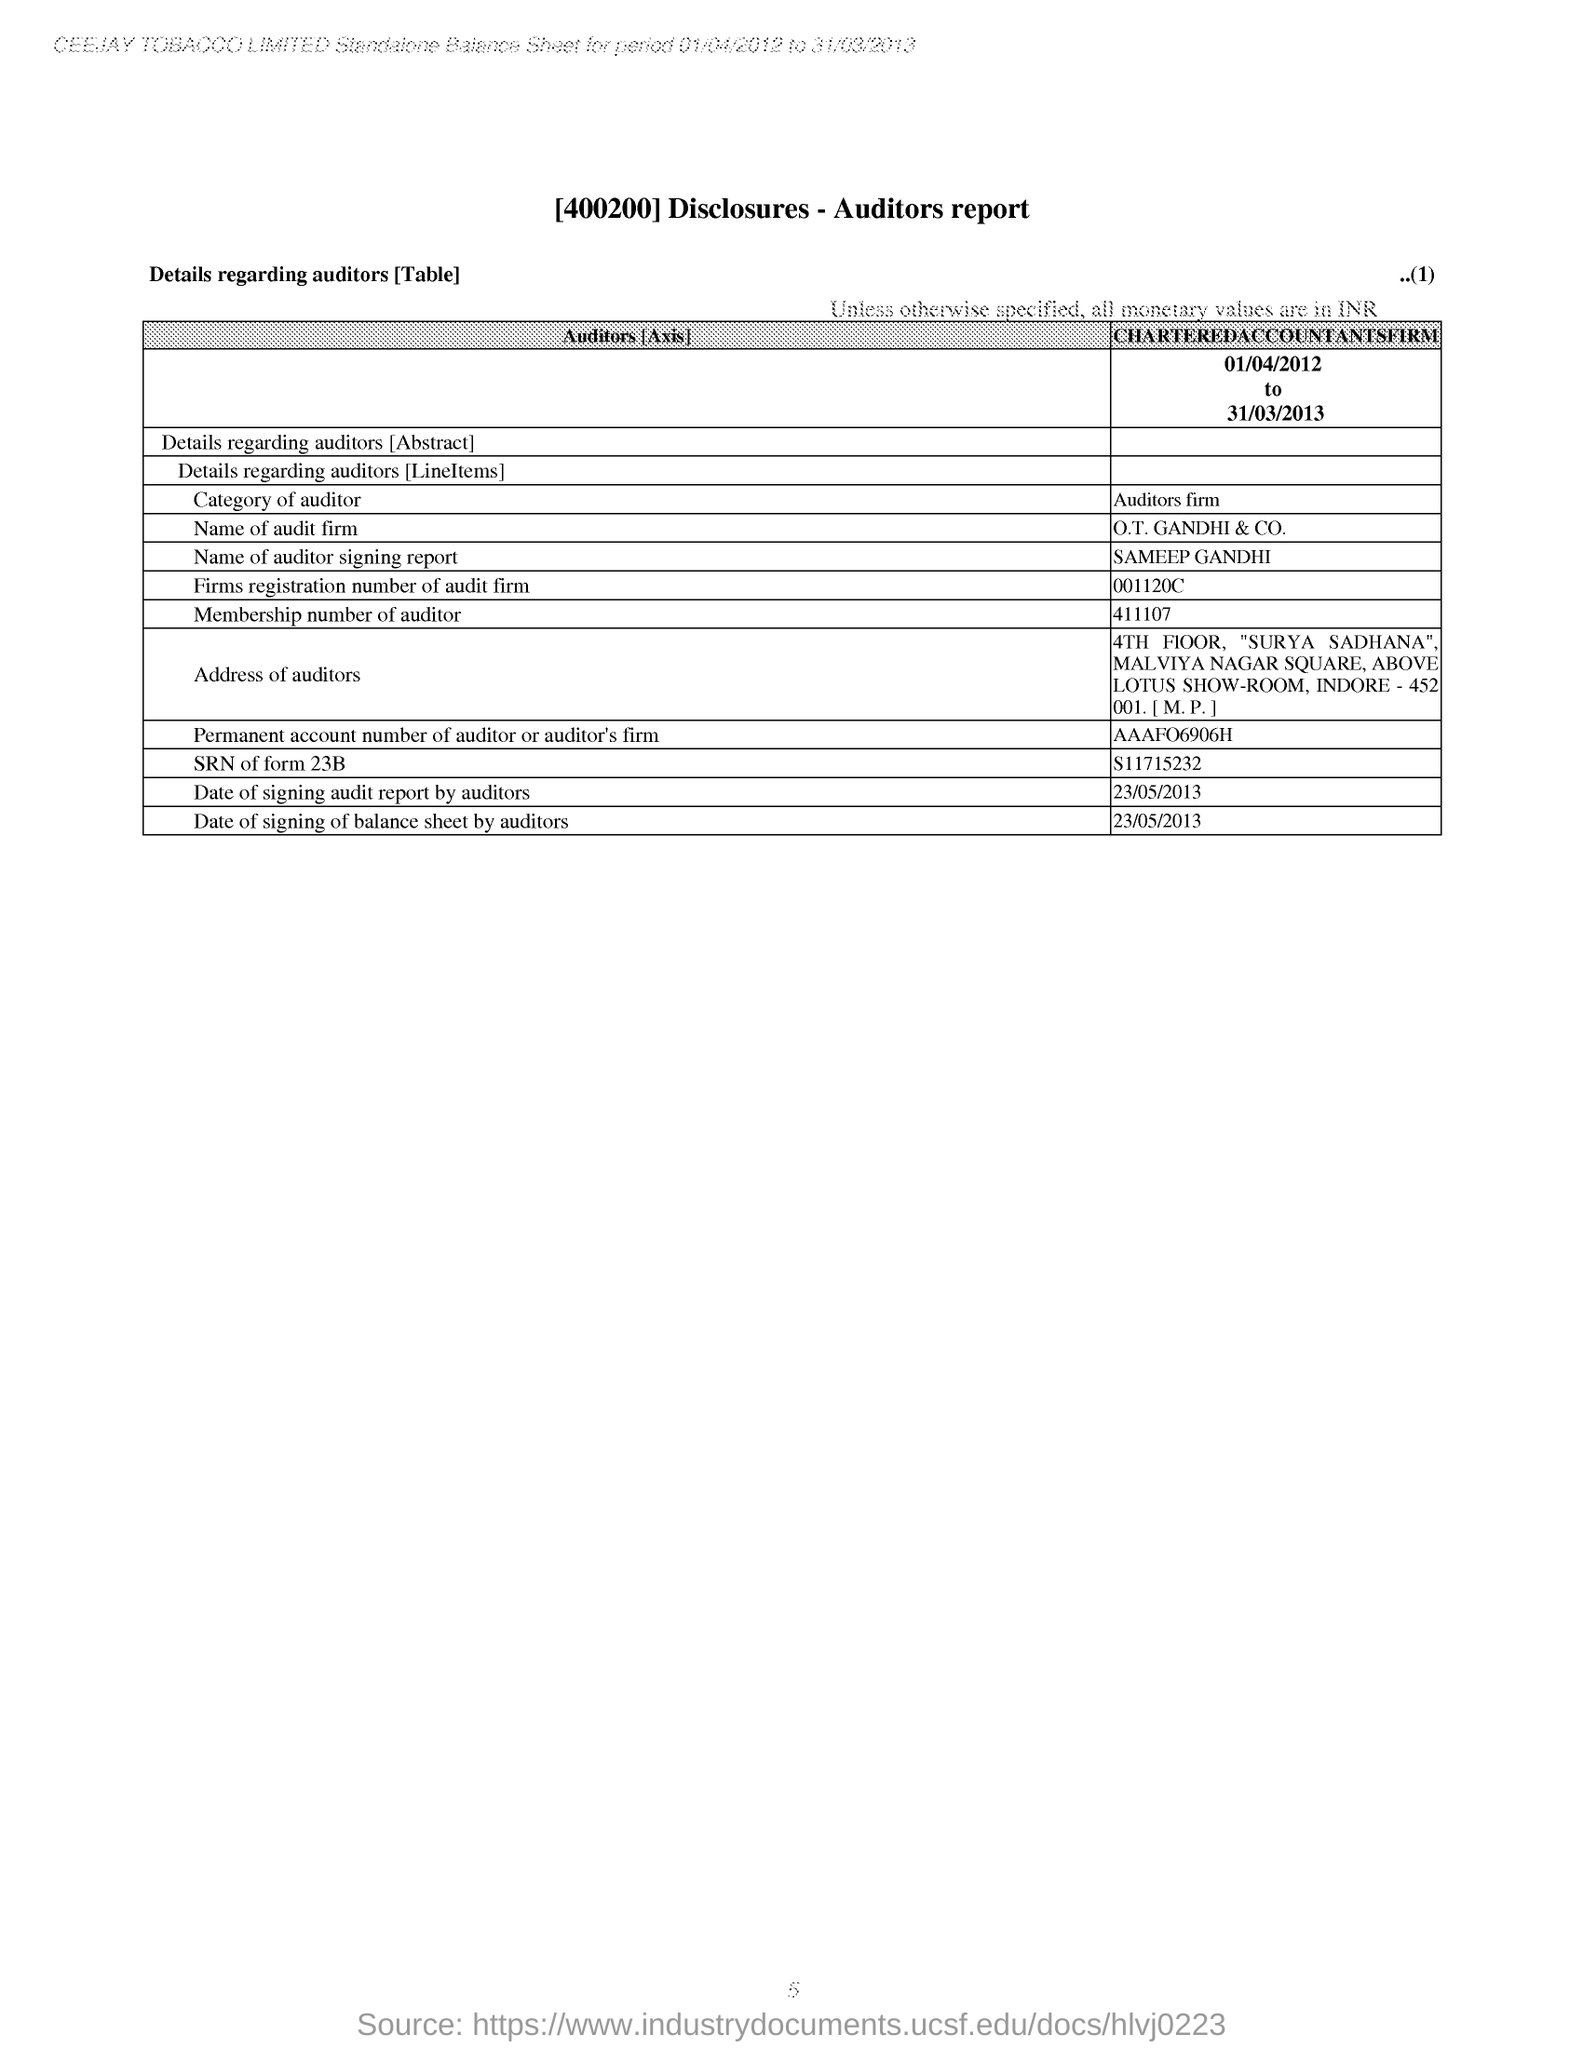Draw attention to some important aspects in this diagram. The table provides information about auditors, including their role and responsibilities. The auditor mentioned in the report is named SAMEEP GANDHI. The city mentioned in the address of the auditor is Indore. The membership number of the auditor mentioned in the report is 411107. 